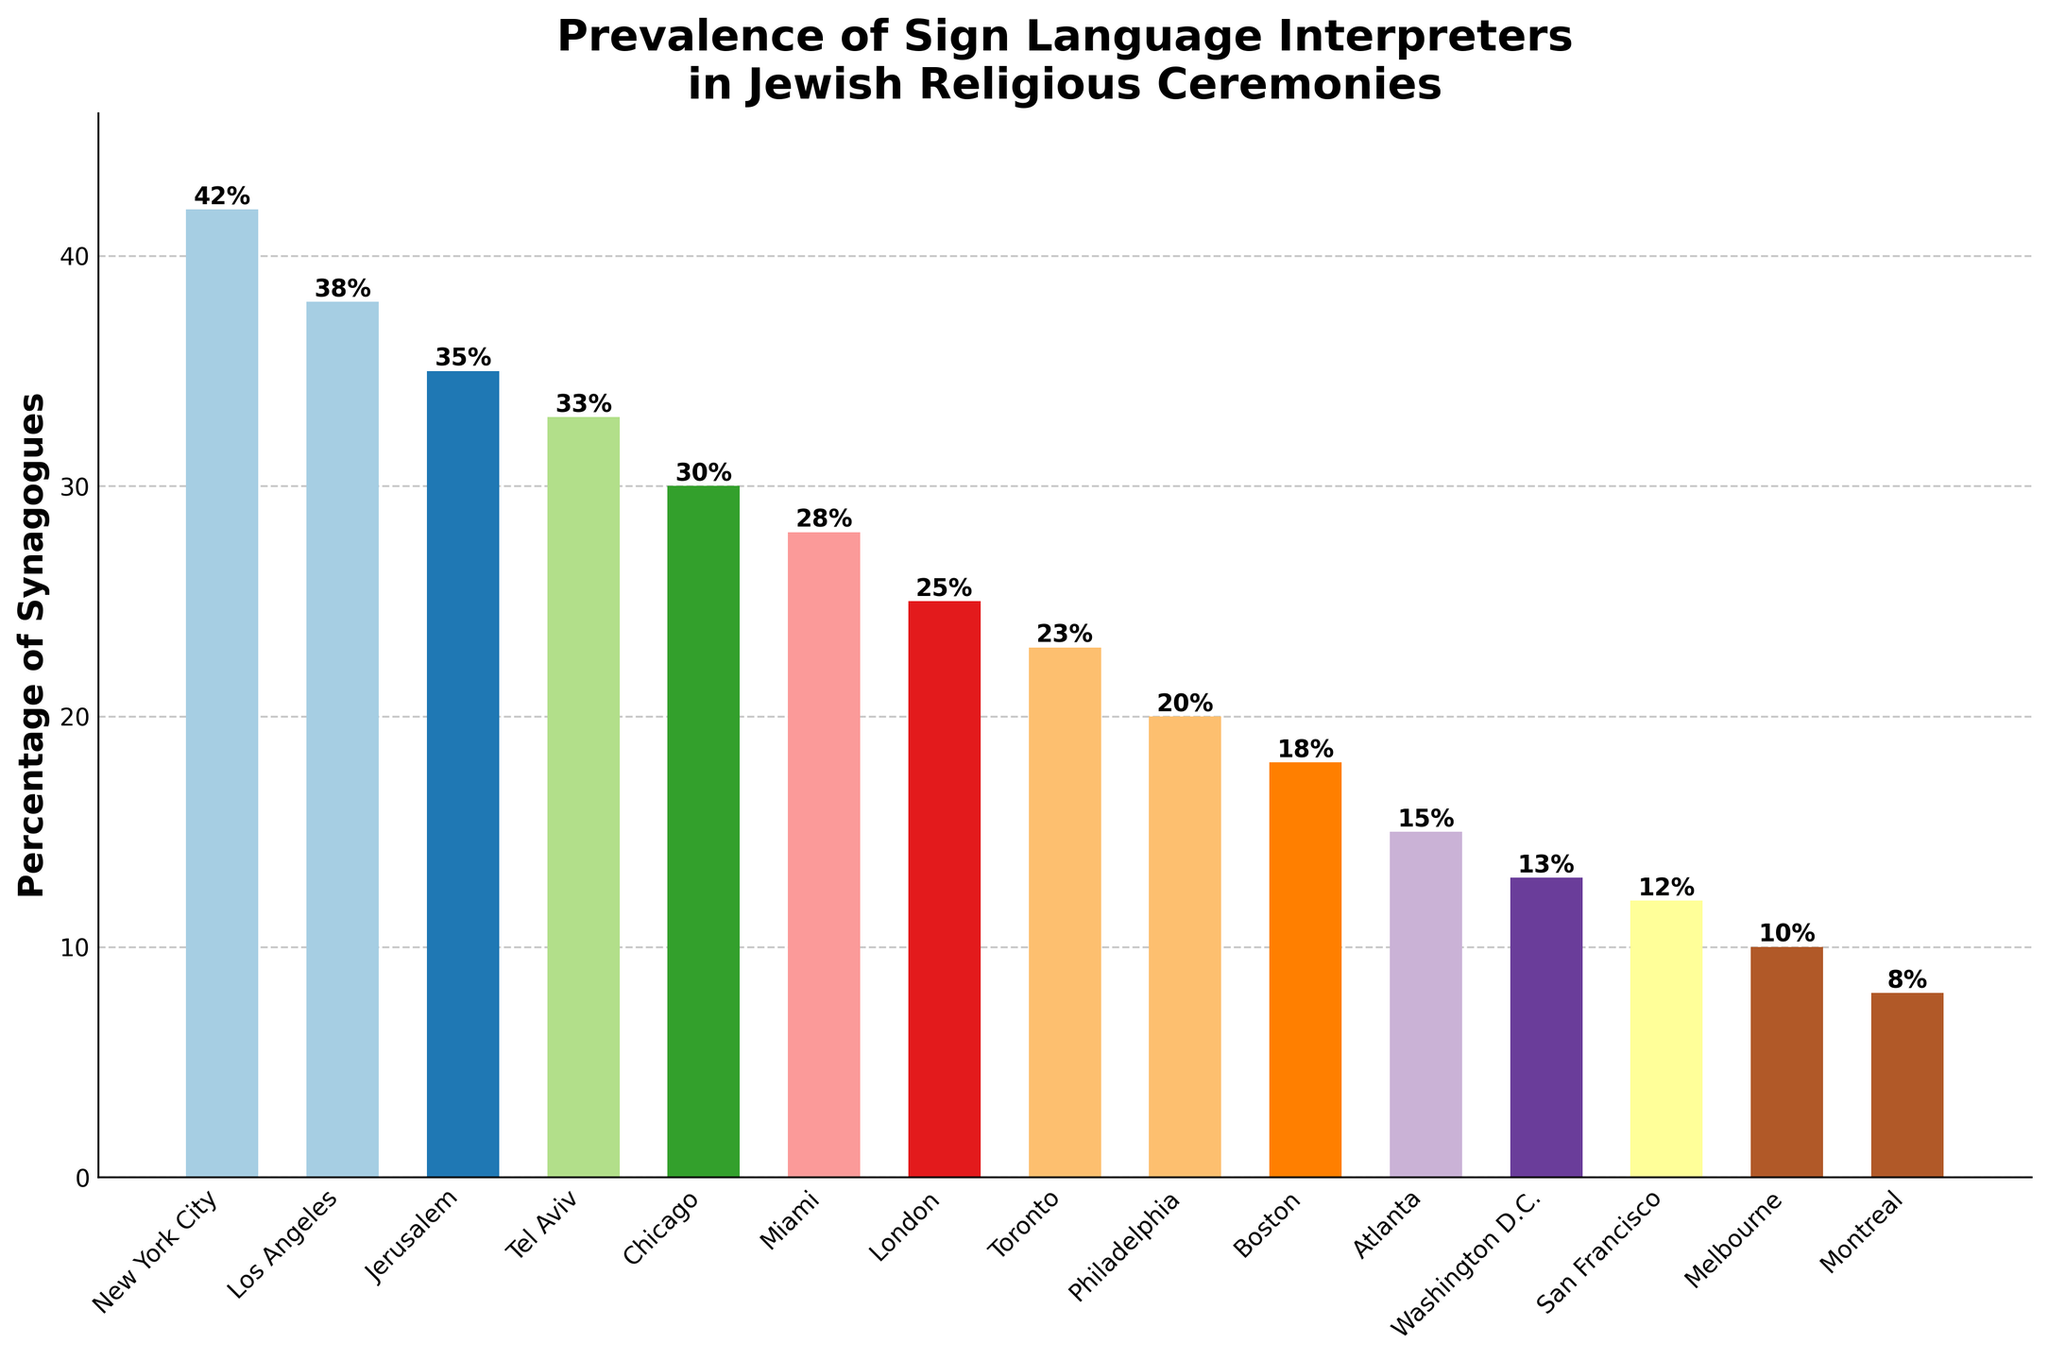How many cities have more than 30% of synagogues with sign language interpreters? First, identify cities with over 30% from the chart: New York City, Los Angeles, Jerusalem, Tel Aviv, Chicago. Count these cities.
Answer: 5 Which city has the highest percentage of synagogues with sign language interpreters? Look for the tallest bar in the chart. New York City has the highest percentage at 42%.
Answer: New York City How much higher is the percentage of synagogues with sign language interpreters in Los Angeles compared to Boston? Find percentages for Los Angeles (38%) and Boston (18%). Calculate the difference: 38% - 18%.
Answer: 20% What is the total percentage of synagogues with sign language interpreters in Philadelphia, Toronto, and Miami? Add percentages: Philadelphia (20%) + Toronto (23%) + Miami (28%) = 71%.
Answer: 71% Which two cities have the closest percentage of synagogues with sign language interpreters? Look for bars with similar heights. Tel Aviv (33%) and Jerusalem (35%) have a 2% difference.
Answer: Tel Aviv and Jerusalem What's the average percentage of synagogues with sign language interpreters across all cities? Sum all percentages and divide by number of cities: (42+38+35+33+30+28+25+23+20+18+15+13+12+10+8) / 15. Total = 350, average = 350 / 15 = 23.33.
Answer: 23.33 What is the median percentage for the synagogues with sign language interpreters? Order the percentages and find the middle value: 42, 38, 35, 33, 30, 28, 25, 23, 20, 18, 15, 13, 12, 10, 8. Median is the 8th value in the ordered list = 23.
Answer: 23 Which city has the lowest percentage? Identify the shortest bar. Montreal has the shortest bar with 8%.
Answer: Montreal How many cities have less than 20% of synagogues with sign language interpreters? Identify cities under 20%: Boston, Atlanta, Washington D.C., San Francisco, Melbourne, Montreal. Count these cities.
Answer: 6 What percentage of synagogues in New York City and London combined have sign language interpreters? Add percentages for New York City (42%) and London (25%): 42% + 25% = 67%.
Answer: 67% 